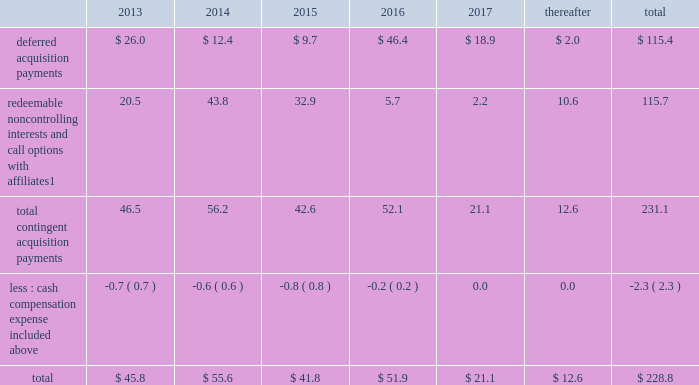Notes to consolidated financial statements 2013 ( continued ) ( amounts in millions , except per share amounts ) guarantees we have guaranteed certain obligations of our subsidiaries relating principally to operating leases and credit facilities of certain subsidiaries .
The amount of parent company guarantees on lease obligations was $ 410.3 and $ 385.1 as of december 31 , 2012 and 2011 , respectively , and the amount of parent company guarantees primarily relating to credit facilities was $ 283.4 and $ 327.5 as of december 31 , 2012 and 2011 , respectively .
In the event of non-payment by the applicable subsidiary of the obligations covered by a guarantee , we would be obligated to pay the amounts covered by that guarantee .
As of december 31 , 2012 , there were no material assets pledged as security for such parent company guarantees .
Contingent acquisition obligations the table details the estimated future contingent acquisition obligations payable in cash as of december 31 .
1 we have entered into certain acquisitions that contain both redeemable noncontrolling interests and call options with similar terms and conditions .
We have certain redeemable noncontrolling interests that are exercisable at the discretion of the noncontrolling equity owners as of december 31 , 2012 .
These estimated payments of $ 16.4 are included within the total payments expected to be made in 2013 , and will continue to be carried forward into 2014 or beyond until exercised or expired .
Redeemable noncontrolling interests are included in the table at current exercise price payable in cash , not at applicable redemption value in accordance with the authoritative guidance for classification and measurement of redeemable securities .
The estimated amounts listed would be paid in the event of exercise at the earliest exercise date .
See note 6 for further information relating to the payment structure of our acquisitions .
All payments are contingent upon achieving projected operating performance targets and satisfying other conditions specified in the related agreements and are subject to revisions as the earn-out periods progress .
Legal matters we are involved in various legal proceedings , and subject to investigations , inspections , audits , inquiries and similar actions by governmental authorities , arising in the normal course of business .
We evaluate all cases each reporting period and record liabilities for losses from legal proceedings when we determine that it is probable that the outcome in a legal proceeding will be unfavorable and the amount , or potential range , of loss can be reasonably estimated .
In certain cases , we cannot reasonably estimate the potential loss because , for example , the litigation is in its early stages .
While any outcome related to litigation or such governmental proceedings in which we are involved cannot be predicted with certainty , management believes that the outcome of these matters , individually and in the aggregate , will not have a material adverse effect on our financial condition , results of operations or cash flows .
Note 15 : recent accounting standards impairment of indefinite-lived intangible assets in july 2012 , the financial accounting standards board ( 201cfasb 201d ) issued amended guidance to simplify impairment testing of indefinite-lived intangible assets other than goodwill .
The amended guidance permits an entity to first assess qualitative factors to determine whether it is 201cmore likely than not 201d that the indefinite-lived intangible asset is impaired .
If , after assessing qualitative factors , an entity concludes that it is not 201cmore likely than not 201d that the indefinite-lived intangible .
What percentage of total estimated future contingent acquisition obligations payable in cash occurred in 2015? 
Computations: ((41.8 / 228.8) * 100)
Answer: 18.26923. 